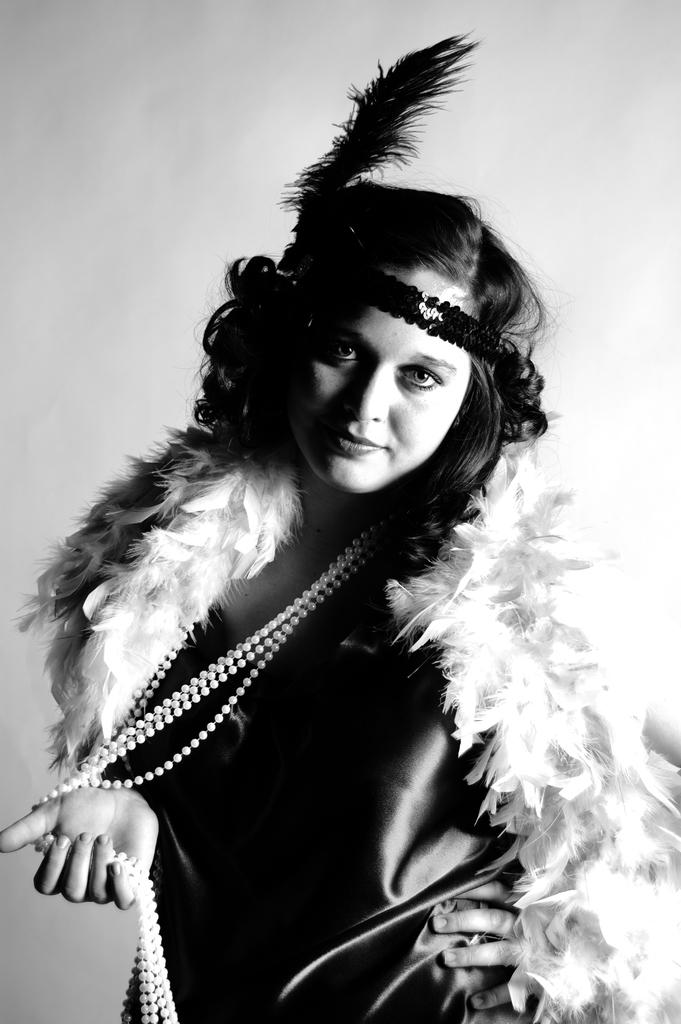Who is the main subject in the image? There is a girl in the image. Where is the girl located in the image? The girl is in the center of the image. What is the girl wearing in the image? The girl is wearing a costume in the image. What type of company is the girl working for in the image? There is no indication in the image that the girl is working for a company, as she is wearing a costume and not engaged in any work-related activities. 